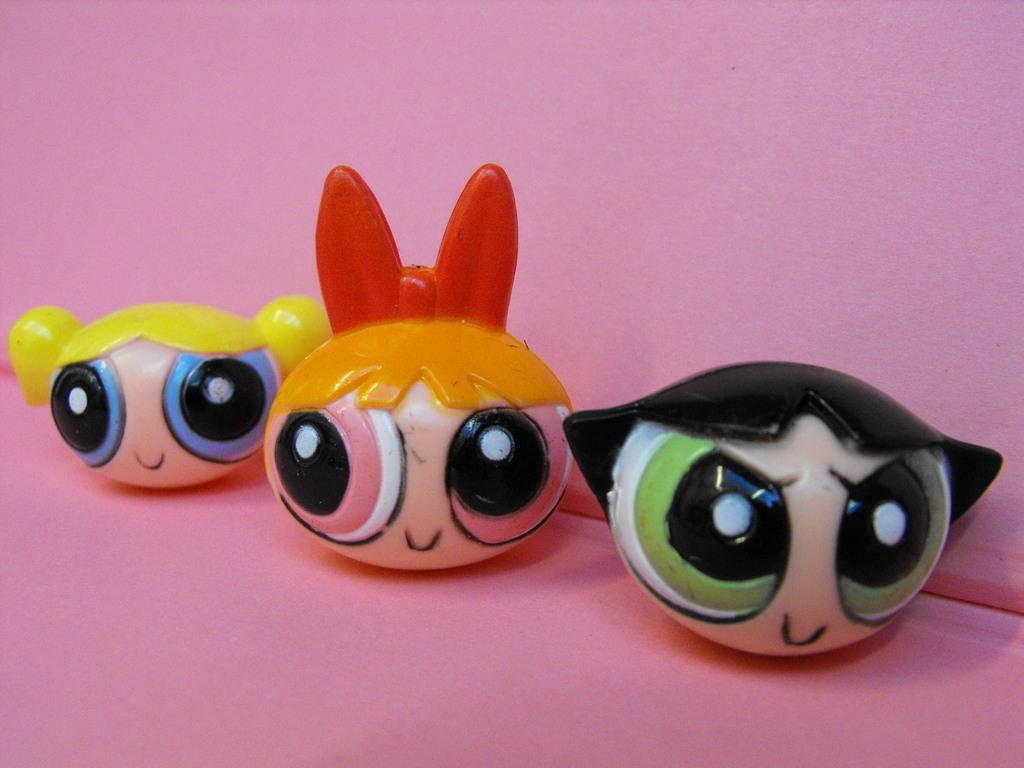What type of objects are in the image? There are toy faces in the image. Where are the toy faces located? The toy faces are on a platform. What can be seen in the background of the image? There is a wall in the background of the image. How many frogs can be seen swimming in the sea in the image? There are no frogs or sea present in the image; it features toy faces on a platform with a wall in the background. 